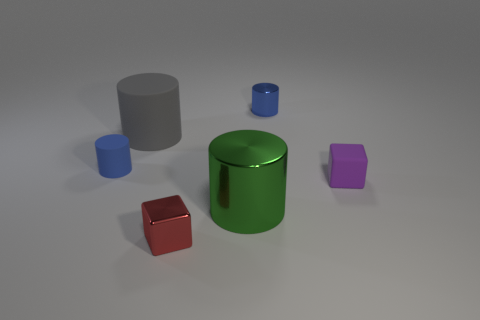What shape is the thing that is the same color as the tiny rubber cylinder?
Your answer should be very brief. Cylinder. There is a shiny cylinder to the left of the tiny shiny cylinder; is its color the same as the metal block?
Offer a very short reply. No. How many rubber objects are the same size as the blue matte cylinder?
Keep it short and to the point. 1. What is the shape of the small red thing that is made of the same material as the big green object?
Make the answer very short. Cube. Is there a big rubber cylinder that has the same color as the tiny rubber cylinder?
Make the answer very short. No. What is the large green thing made of?
Ensure brevity in your answer.  Metal. What number of things are either big gray cylinders or tiny blue objects?
Ensure brevity in your answer.  3. What size is the rubber thing right of the gray rubber thing?
Provide a short and direct response. Small. How many other objects are there of the same material as the red cube?
Ensure brevity in your answer.  2. Is there a big green metallic cylinder that is to the right of the tiny cube to the right of the red thing?
Give a very brief answer. No. 